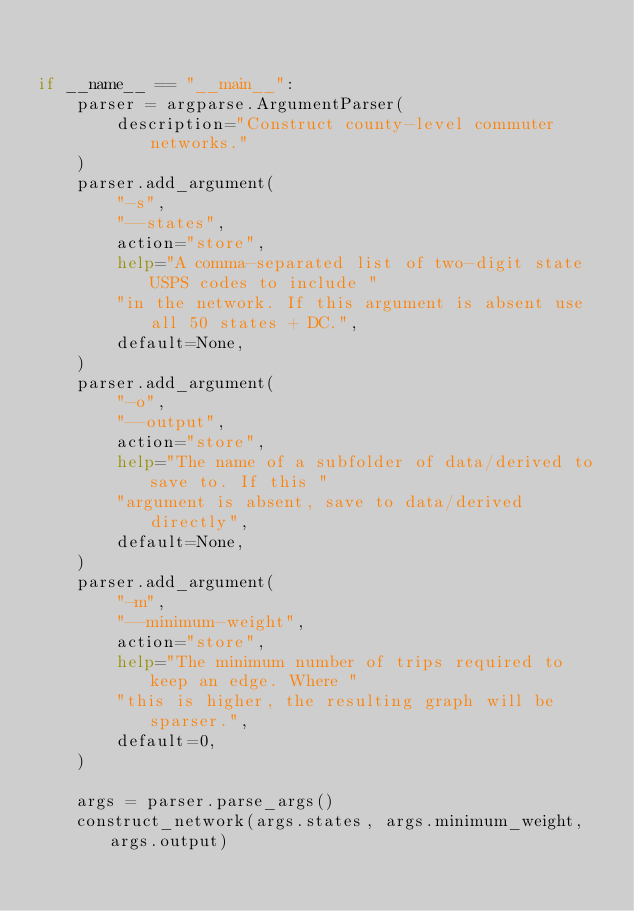Convert code to text. <code><loc_0><loc_0><loc_500><loc_500><_Python_>

if __name__ == "__main__":
    parser = argparse.ArgumentParser(
        description="Construct county-level commuter networks."
    )
    parser.add_argument(
        "-s",
        "--states",
        action="store",
        help="A comma-separated list of two-digit state USPS codes to include "
        "in the network. If this argument is absent use all 50 states + DC.",
        default=None,
    )
    parser.add_argument(
        "-o",
        "--output",
        action="store",
        help="The name of a subfolder of data/derived to save to. If this "
        "argument is absent, save to data/derived directly",
        default=None,
    )
    parser.add_argument(
        "-m",
        "--minimum-weight",
        action="store",
        help="The minimum number of trips required to keep an edge. Where "
        "this is higher, the resulting graph will be sparser.",
        default=0,
    )

    args = parser.parse_args()
    construct_network(args.states, args.minimum_weight, args.output)
</code> 